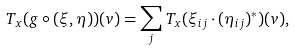Convert formula to latex. <formula><loc_0><loc_0><loc_500><loc_500>T _ { x } ( g \circ ( \xi , \eta ) ) ( v ) = \sum _ { j } T _ { x } ( \xi _ { i j } \cdot ( \eta _ { i j } ) ^ { * } ) ( v ) ,</formula> 